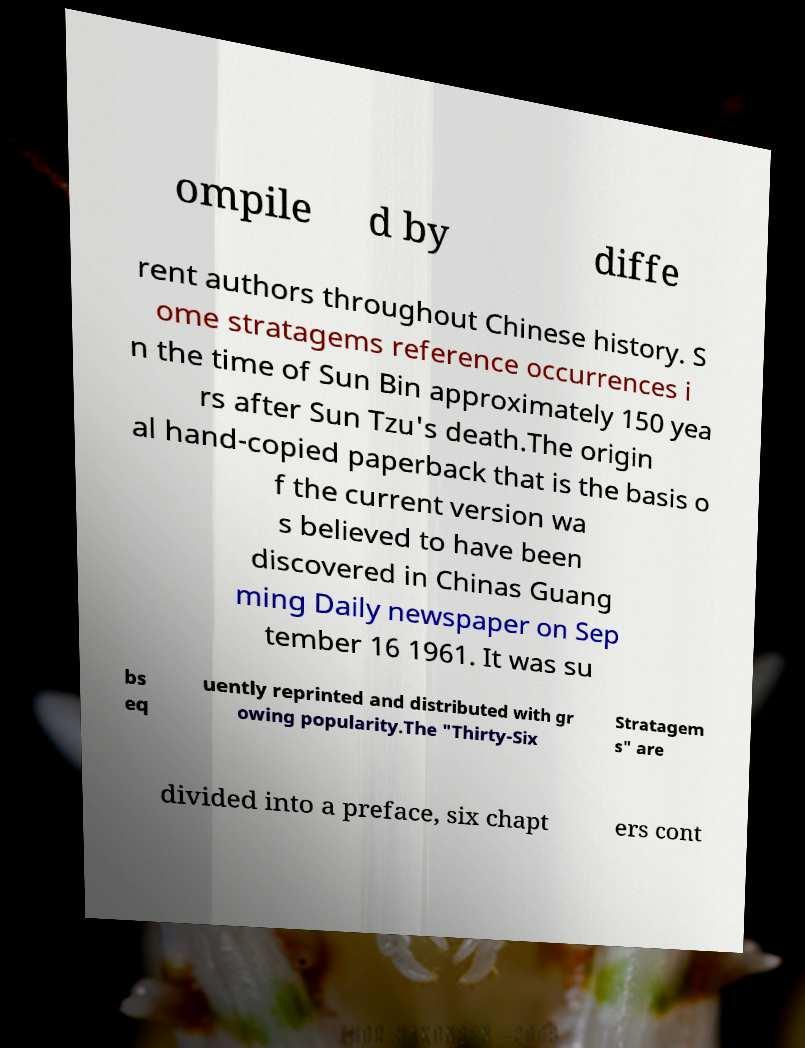For documentation purposes, I need the text within this image transcribed. Could you provide that? ompile d by diffe rent authors throughout Chinese history. S ome stratagems reference occurrences i n the time of Sun Bin approximately 150 yea rs after Sun Tzu's death.The origin al hand-copied paperback that is the basis o f the current version wa s believed to have been discovered in Chinas Guang ming Daily newspaper on Sep tember 16 1961. It was su bs eq uently reprinted and distributed with gr owing popularity.The "Thirty-Six Stratagem s" are divided into a preface, six chapt ers cont 